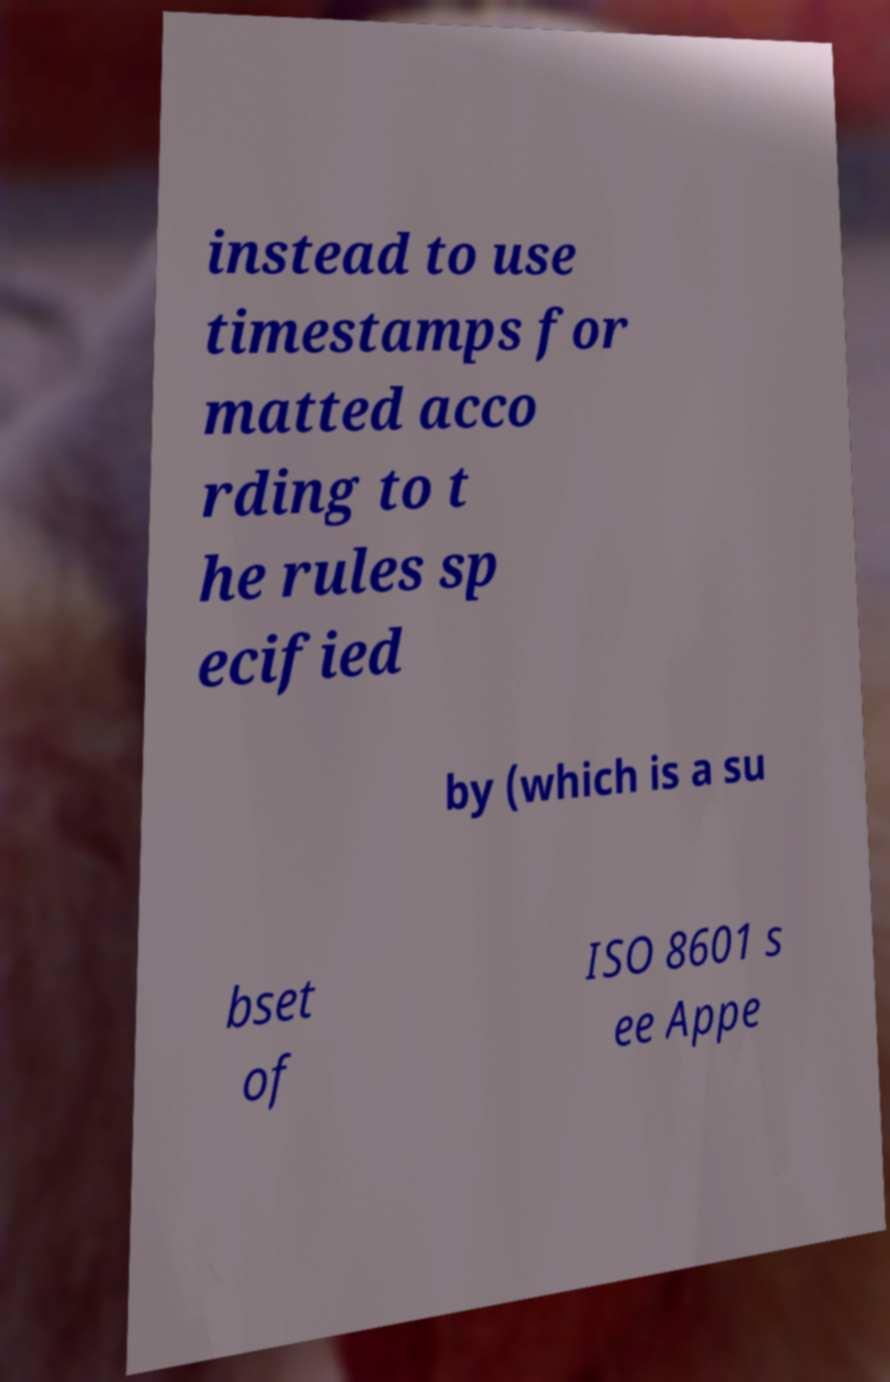Can you accurately transcribe the text from the provided image for me? instead to use timestamps for matted acco rding to t he rules sp ecified by (which is a su bset of ISO 8601 s ee Appe 